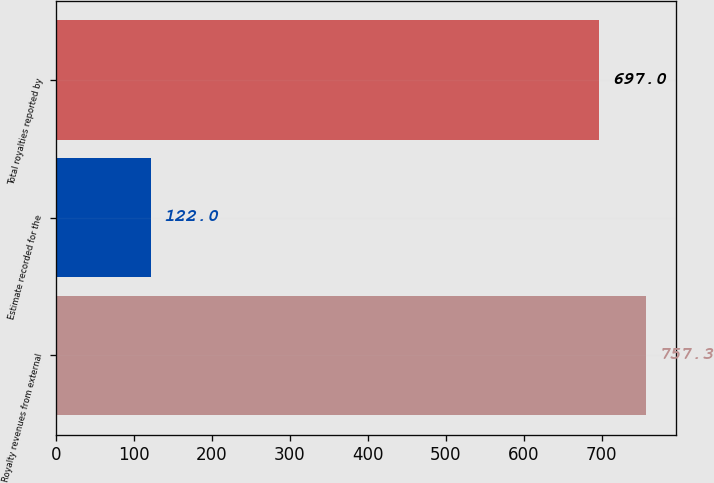Convert chart. <chart><loc_0><loc_0><loc_500><loc_500><bar_chart><fcel>Royalty revenues from external<fcel>Estimate recorded for the<fcel>Total royalties reported by<nl><fcel>757.3<fcel>122<fcel>697<nl></chart> 